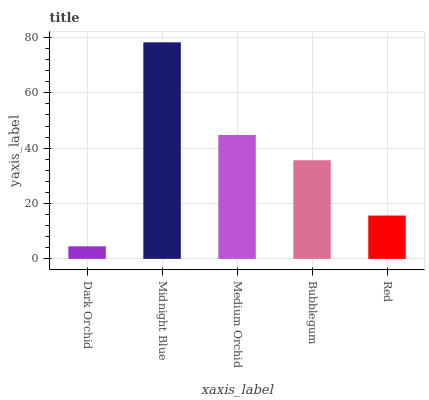Is Dark Orchid the minimum?
Answer yes or no. Yes. Is Midnight Blue the maximum?
Answer yes or no. Yes. Is Medium Orchid the minimum?
Answer yes or no. No. Is Medium Orchid the maximum?
Answer yes or no. No. Is Midnight Blue greater than Medium Orchid?
Answer yes or no. Yes. Is Medium Orchid less than Midnight Blue?
Answer yes or no. Yes. Is Medium Orchid greater than Midnight Blue?
Answer yes or no. No. Is Midnight Blue less than Medium Orchid?
Answer yes or no. No. Is Bubblegum the high median?
Answer yes or no. Yes. Is Bubblegum the low median?
Answer yes or no. Yes. Is Medium Orchid the high median?
Answer yes or no. No. Is Midnight Blue the low median?
Answer yes or no. No. 